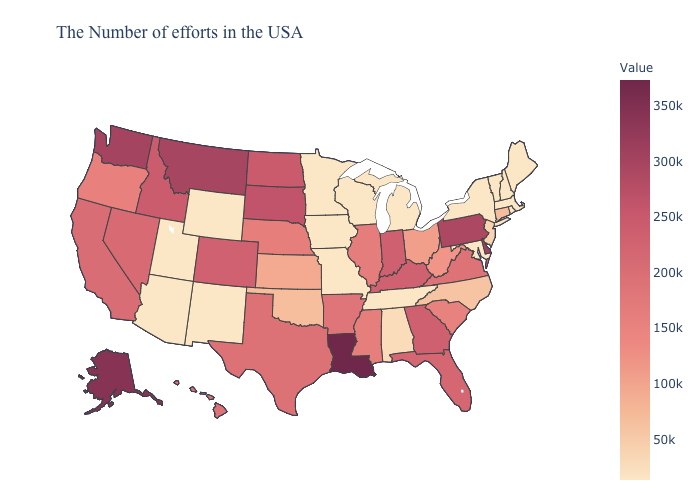Is the legend a continuous bar?
Give a very brief answer. Yes. Among the states that border Massachusetts , does Connecticut have the lowest value?
Concise answer only. No. 